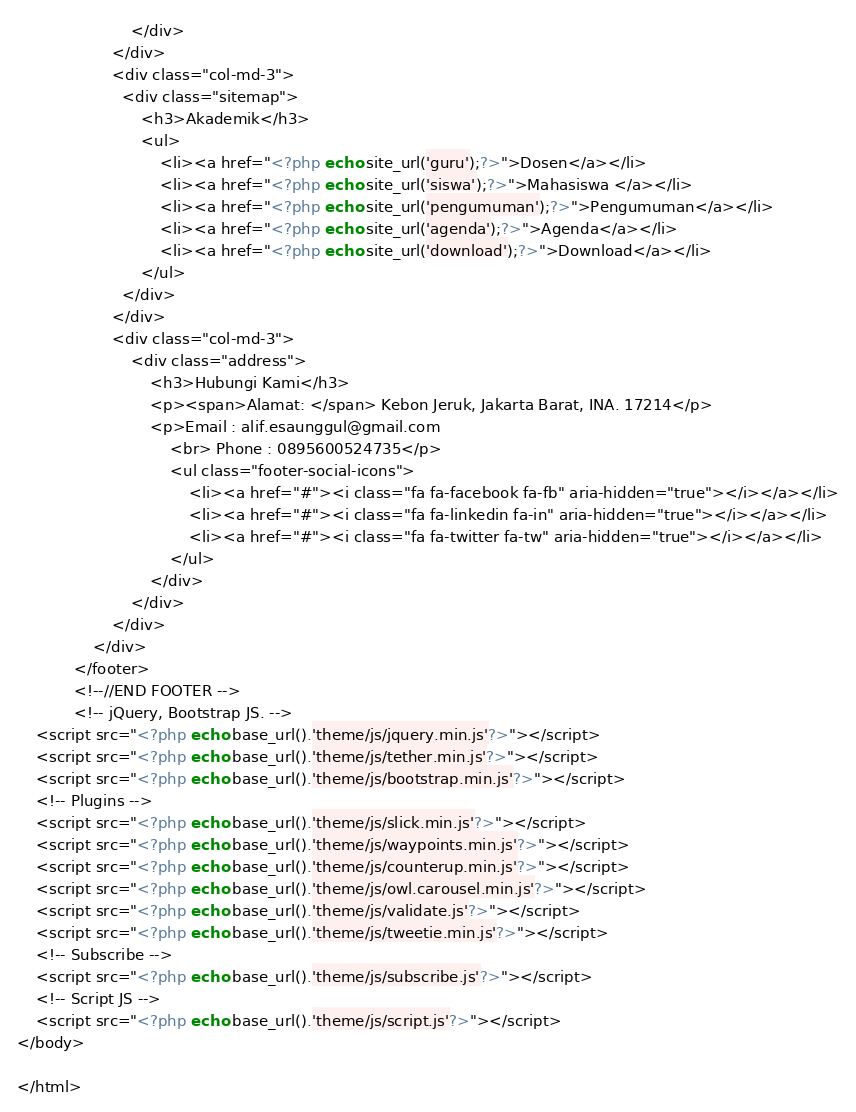<code> <loc_0><loc_0><loc_500><loc_500><_PHP_>                        </div>
                    </div>
                    <div class="col-md-3">
                      <div class="sitemap">
                          <h3>Akademik</h3>
                          <ul>
                              <li><a href="<?php echo site_url('guru');?>">Dosen</a></li>
                              <li><a href="<?php echo site_url('siswa');?>">Mahasiswa </a></li>
                              <li><a href="<?php echo site_url('pengumuman');?>">Pengumuman</a></li>
                              <li><a href="<?php echo site_url('agenda');?>">Agenda</a></li>
                              <li><a href="<?php echo site_url('download');?>">Download</a></li>
                          </ul>
                      </div>
                    </div>
                    <div class="col-md-3">
                        <div class="address">
                            <h3>Hubungi Kami</h3>
                            <p><span>Alamat: </span> Kebon Jeruk, Jakarta Barat, INA. 17214</p>
                            <p>Email : alif.esaunggul@gmail.com
                                <br> Phone : 0895600524735</p>
                                <ul class="footer-social-icons">
                                    <li><a href="#"><i class="fa fa-facebook fa-fb" aria-hidden="true"></i></a></li>
                                    <li><a href="#"><i class="fa fa-linkedin fa-in" aria-hidden="true"></i></a></li>
                                    <li><a href="#"><i class="fa fa-twitter fa-tw" aria-hidden="true"></i></a></li>
                                </ul>
                            </div>
                        </div>
                    </div>
                </div>
            </footer>
            <!--//END FOOTER -->
            <!-- jQuery, Bootstrap JS. -->
    <script src="<?php echo base_url().'theme/js/jquery.min.js'?>"></script>
    <script src="<?php echo base_url().'theme/js/tether.min.js'?>"></script>
    <script src="<?php echo base_url().'theme/js/bootstrap.min.js'?>"></script>
    <!-- Plugins -->
    <script src="<?php echo base_url().'theme/js/slick.min.js'?>"></script>
    <script src="<?php echo base_url().'theme/js/waypoints.min.js'?>"></script>
    <script src="<?php echo base_url().'theme/js/counterup.min.js'?>"></script>
    <script src="<?php echo base_url().'theme/js/owl.carousel.min.js'?>"></script>
    <script src="<?php echo base_url().'theme/js/validate.js'?>"></script>
    <script src="<?php echo base_url().'theme/js/tweetie.min.js'?>"></script>
    <!-- Subscribe -->
    <script src="<?php echo base_url().'theme/js/subscribe.js'?>"></script>
    <!-- Script JS -->
    <script src="<?php echo base_url().'theme/js/script.js'?>"></script>
</body>

</html>
</code> 